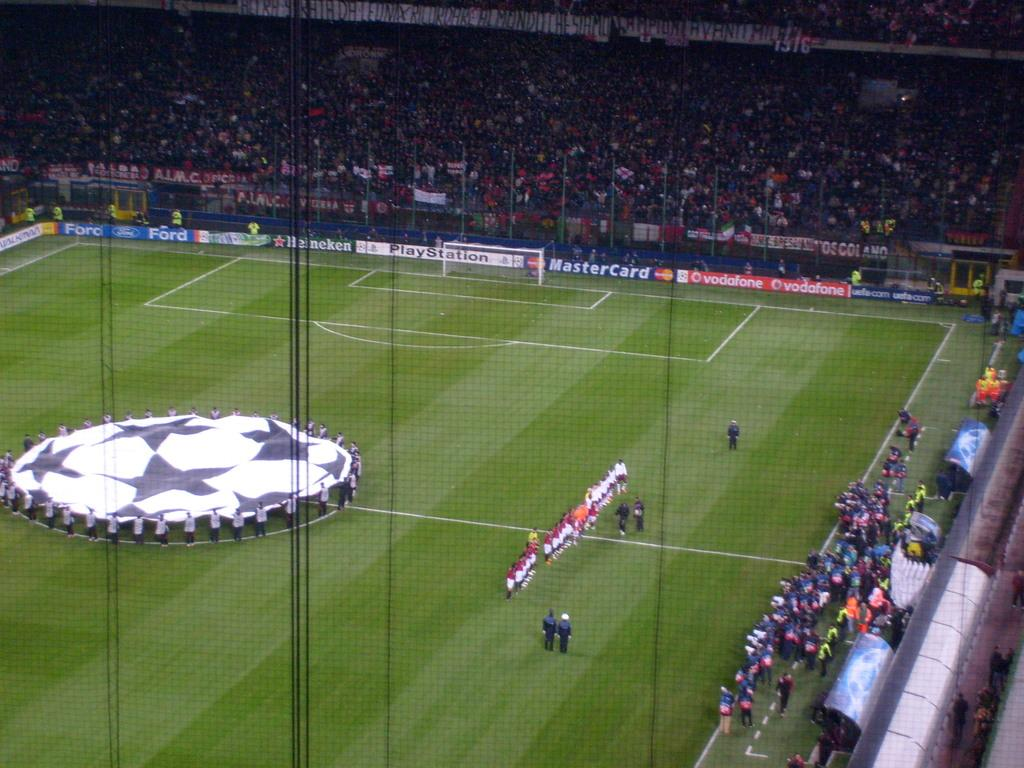<image>
Write a terse but informative summary of the picture. a field that has a sign on the bottom that is advertising Ford 